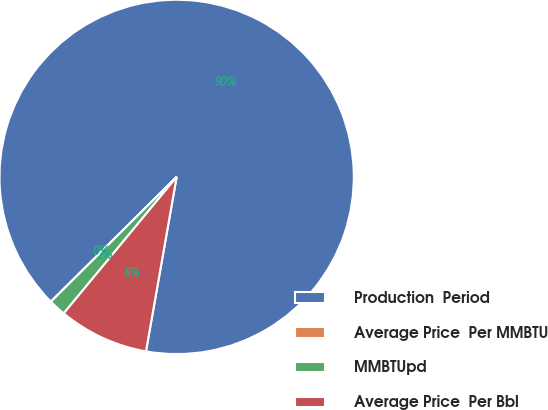Convert chart. <chart><loc_0><loc_0><loc_500><loc_500><pie_chart><fcel>Production  Period<fcel>Average Price  Per MMBTU<fcel>MMBTUpd<fcel>Average Price  Per Bbl<nl><fcel>90.2%<fcel>0.0%<fcel>1.56%<fcel>8.23%<nl></chart> 